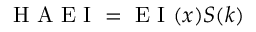Convert formula to latex. <formula><loc_0><loc_0><loc_500><loc_500>H A E I = E I ( x ) S ( k )</formula> 